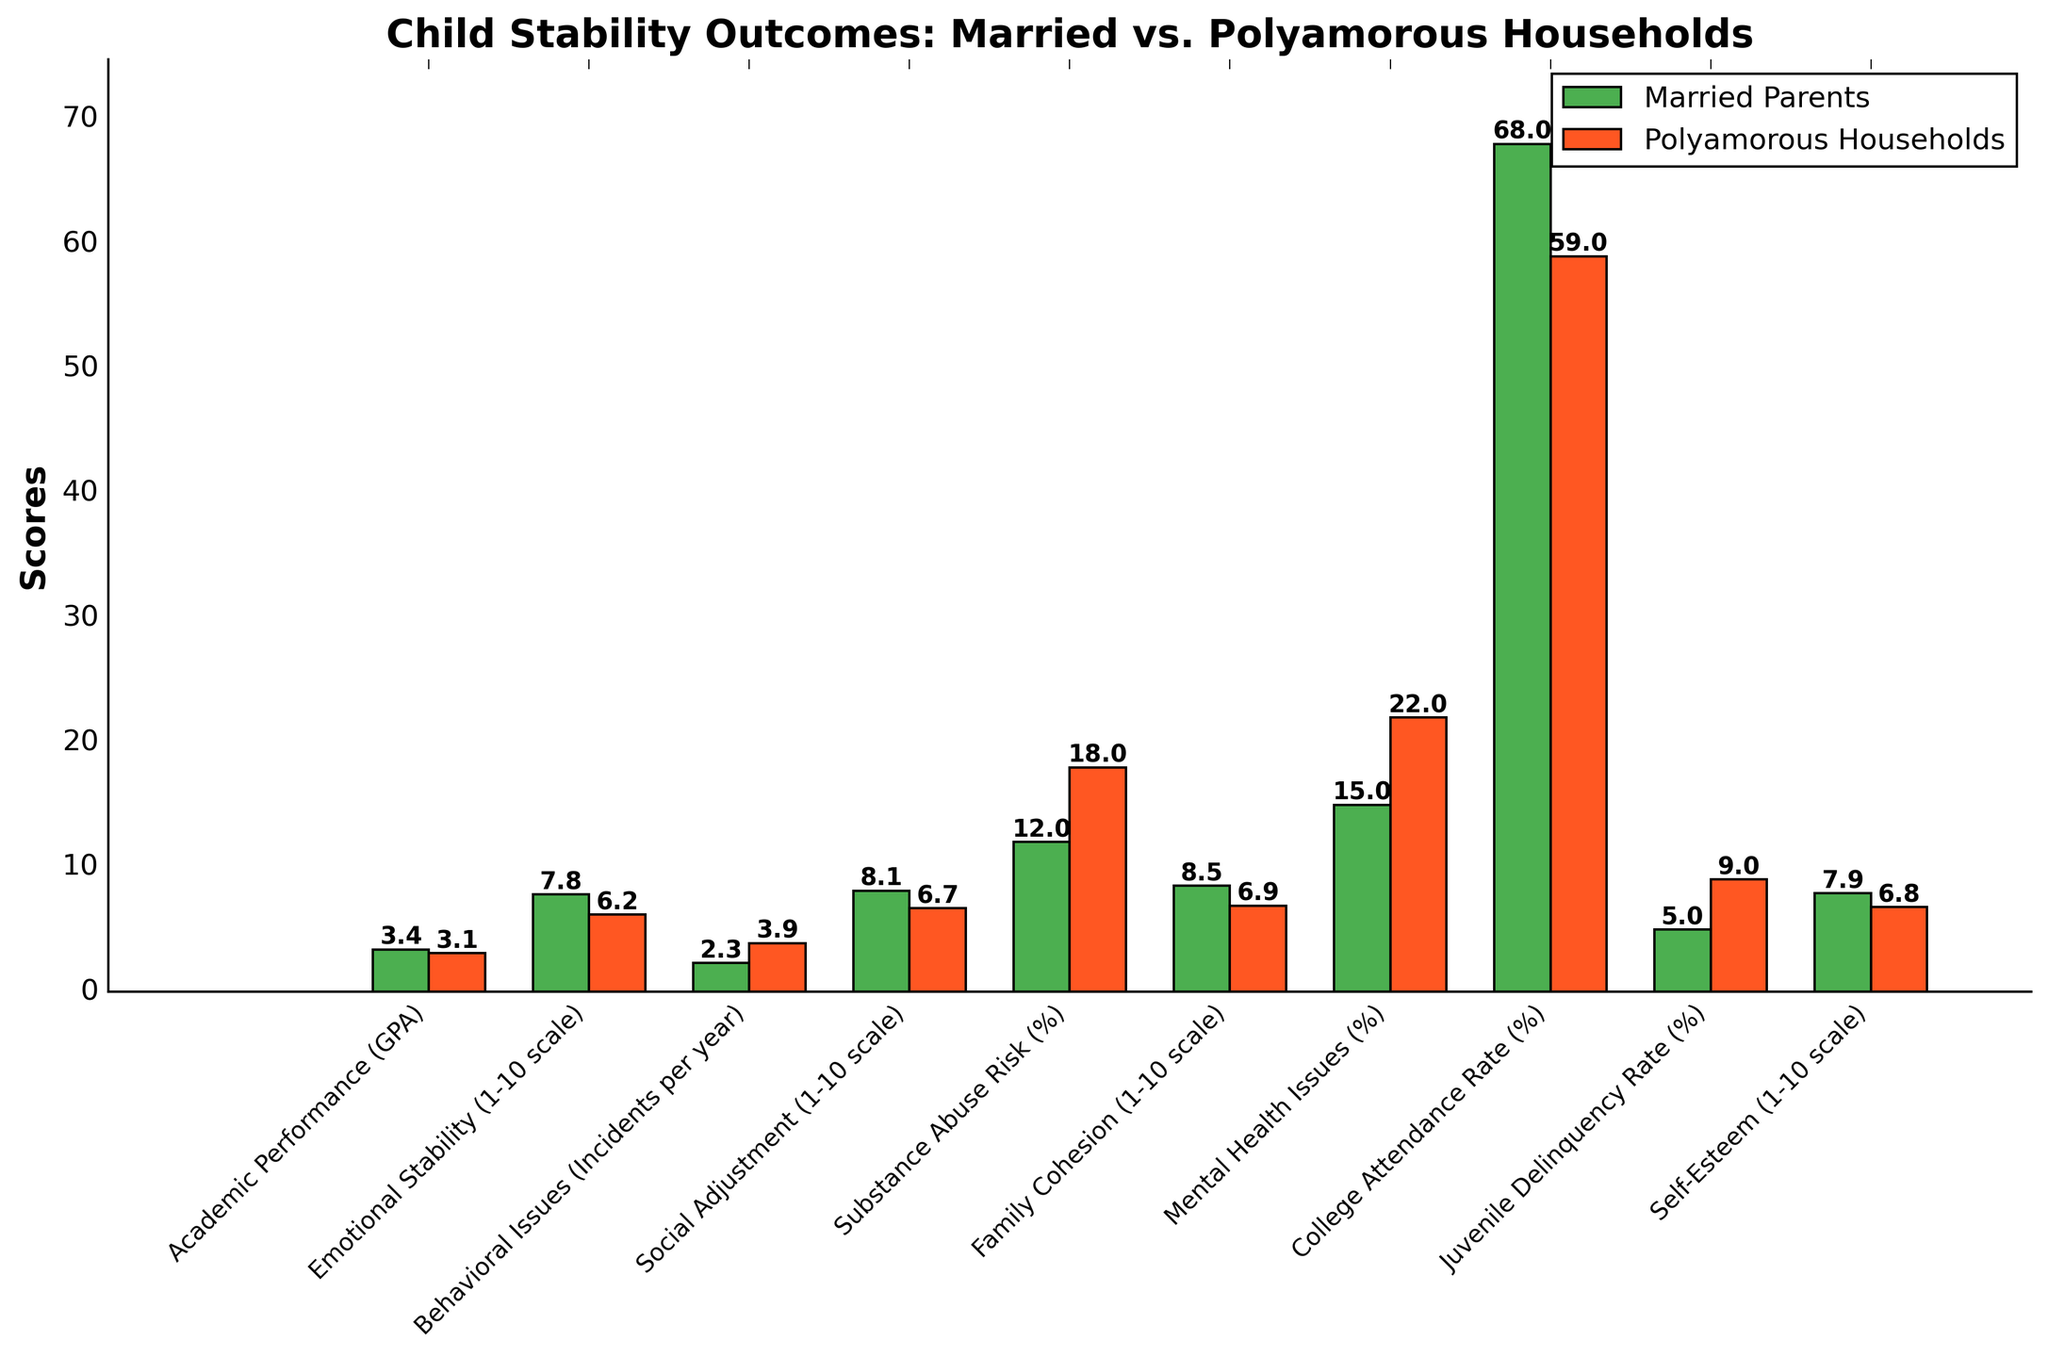What's the difference in emotional stability scores between children in married households and those in polyamorous households? The emotional stability score for children in married households is 7.8, while for those in polyamorous households, it is 6.2. Subtracting the latter from the former gives the difference: 7.8 - 6.2 = 1.6
Answer: 1.6 What percentage of children in polyamorous households attend college compared to those in married households? The college attendance rate for children in polyamorous households is 59%, while for those in married households, it is 68%. To compare, we look at both percentages: 68% (married) vs. 59% (polyamorous)
Answer: 59% vs. 68% Which household type has a higher rate of behavioral issues among children? The rate of behavioral issues in polyamorous households is 3.9 incidents per year compared to 2.3 incidents per year in married households. Since 3.9 is greater than 2.3, polyamorous households have a higher rate of behavioral issues.
Answer: Polyamorous households How do the family cohesion scores compare between children in married vs. polyamorous households? The family cohesion score for children in married households is 8.5, while for those in polyamorous households, it is 6.9. Since 8.5 is greater than 6.9, married households have higher family cohesion.
Answer: Married households What are the differences in substance abuse risk between children in married and polyamorous households? The substance abuse risk for children in married households is 12%, while for those in polyamorous households, it is 18%. Subtracting the former from the latter gives the difference: 18% - 12% = 6%
Answer: 6% How many percentage points higher is the juvenile delinquency rate in polyamorous households compared to married households? The juvenile delinquency rate in polyamorous households is 9%, and in married households, it is 5%. Subtracting the latter from the former gives the difference: 9% - 5% = 4%
Answer: 4% Which household type shows better social adjustment scores for children? The social adjustment score for children in married households is 8.1, while for those in polyamorous households, it is 6.7. Since 8.1 is greater than 6.7, married households show better social adjustment scores.
Answer: Married households 